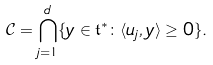<formula> <loc_0><loc_0><loc_500><loc_500>\mathcal { C } = \bigcap _ { j = 1 } ^ { d } \{ y \in \mathfrak { t } ^ { * } \colon \langle u _ { j } , y \rangle \geq 0 \} .</formula> 